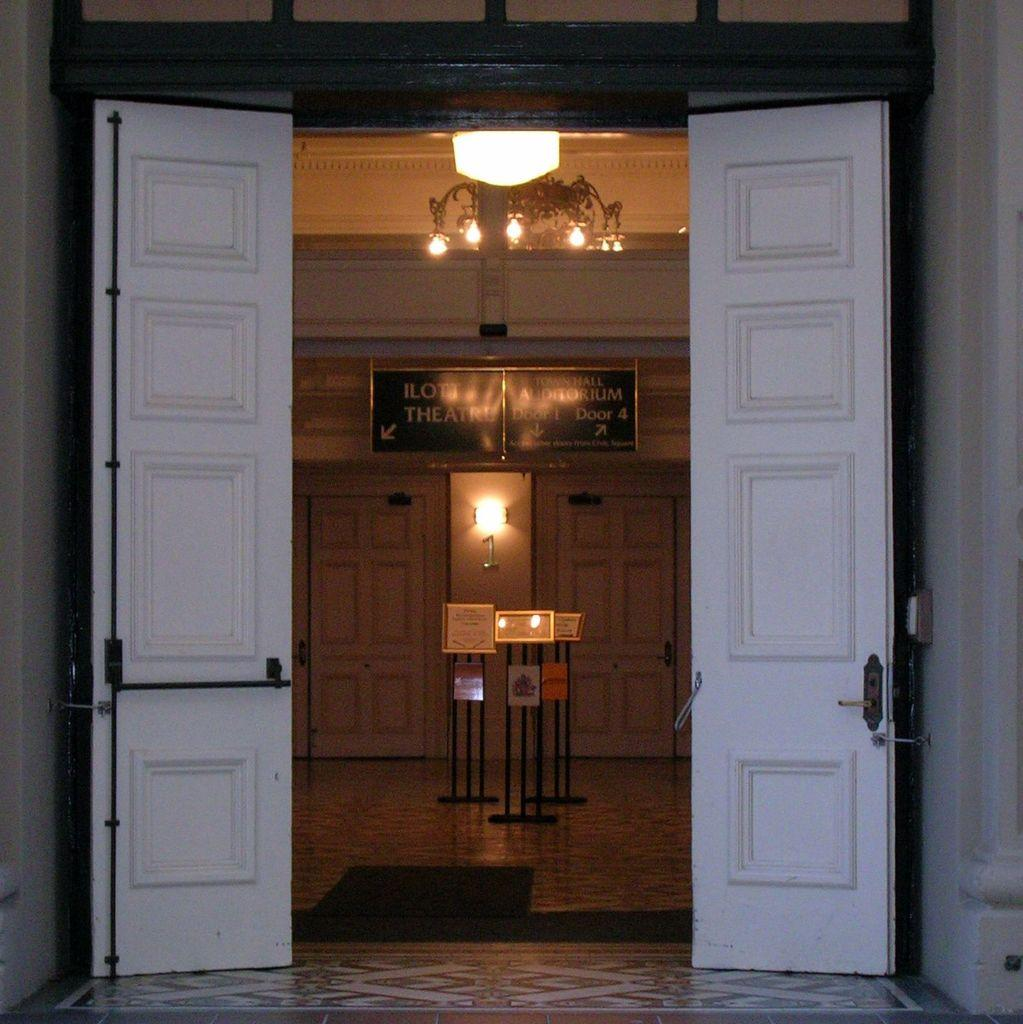What type of objects can be seen in the image? There are lights, boards, and doors visible in the image. What is on the floor in the image? There is a mat on the floor in the image. What is the background of the image composed of? There is a wall in the background of the image. What is the surface that the objects are placed on? There is a floor in the image. Can you hear the tramp laughing in the image? There is no tramp or laughter present in the image; it only contains lights, boards, doors, a floor, a mat, and a wall. 